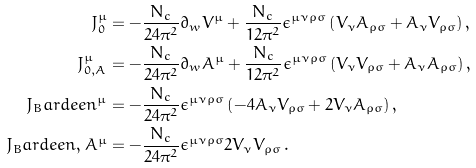<formula> <loc_0><loc_0><loc_500><loc_500>J _ { 0 } ^ { \mu } & = - \frac { N _ { c } } { 2 4 \pi ^ { 2 } } \partial _ { w } V ^ { \mu } + \frac { N _ { c } } { 1 2 \pi ^ { 2 } } \epsilon ^ { \mu \nu \rho \sigma } \left ( V _ { \nu } A _ { \rho \sigma } + A _ { \nu } V _ { \rho \sigma } \right ) , \\ J _ { 0 , A } ^ { \mu } & = - \frac { N _ { c } } { 2 4 \pi ^ { 2 } } \partial _ { w } A ^ { \mu } + \frac { N _ { c } } { 1 2 \pi ^ { 2 } } \epsilon ^ { \mu \nu \rho \sigma } \left ( V _ { \nu } V _ { \rho \sigma } + A _ { \nu } A _ { \rho \sigma } \right ) , \\ J _ { B } a r d e e n ^ { \mu } & = - \frac { N _ { c } } { 2 4 \pi ^ { 2 } } \epsilon ^ { \mu \nu \rho \sigma } \left ( - 4 A _ { \nu } V _ { \rho \sigma } + 2 V _ { \nu } A _ { \rho \sigma } \right ) , \\ J _ { B } a r d e e n , A ^ { \mu } & = - \frac { N _ { c } } { 2 4 \pi ^ { 2 } } \epsilon ^ { \mu \nu \rho \sigma } 2 V _ { \nu } V _ { \rho \sigma } \, .</formula> 